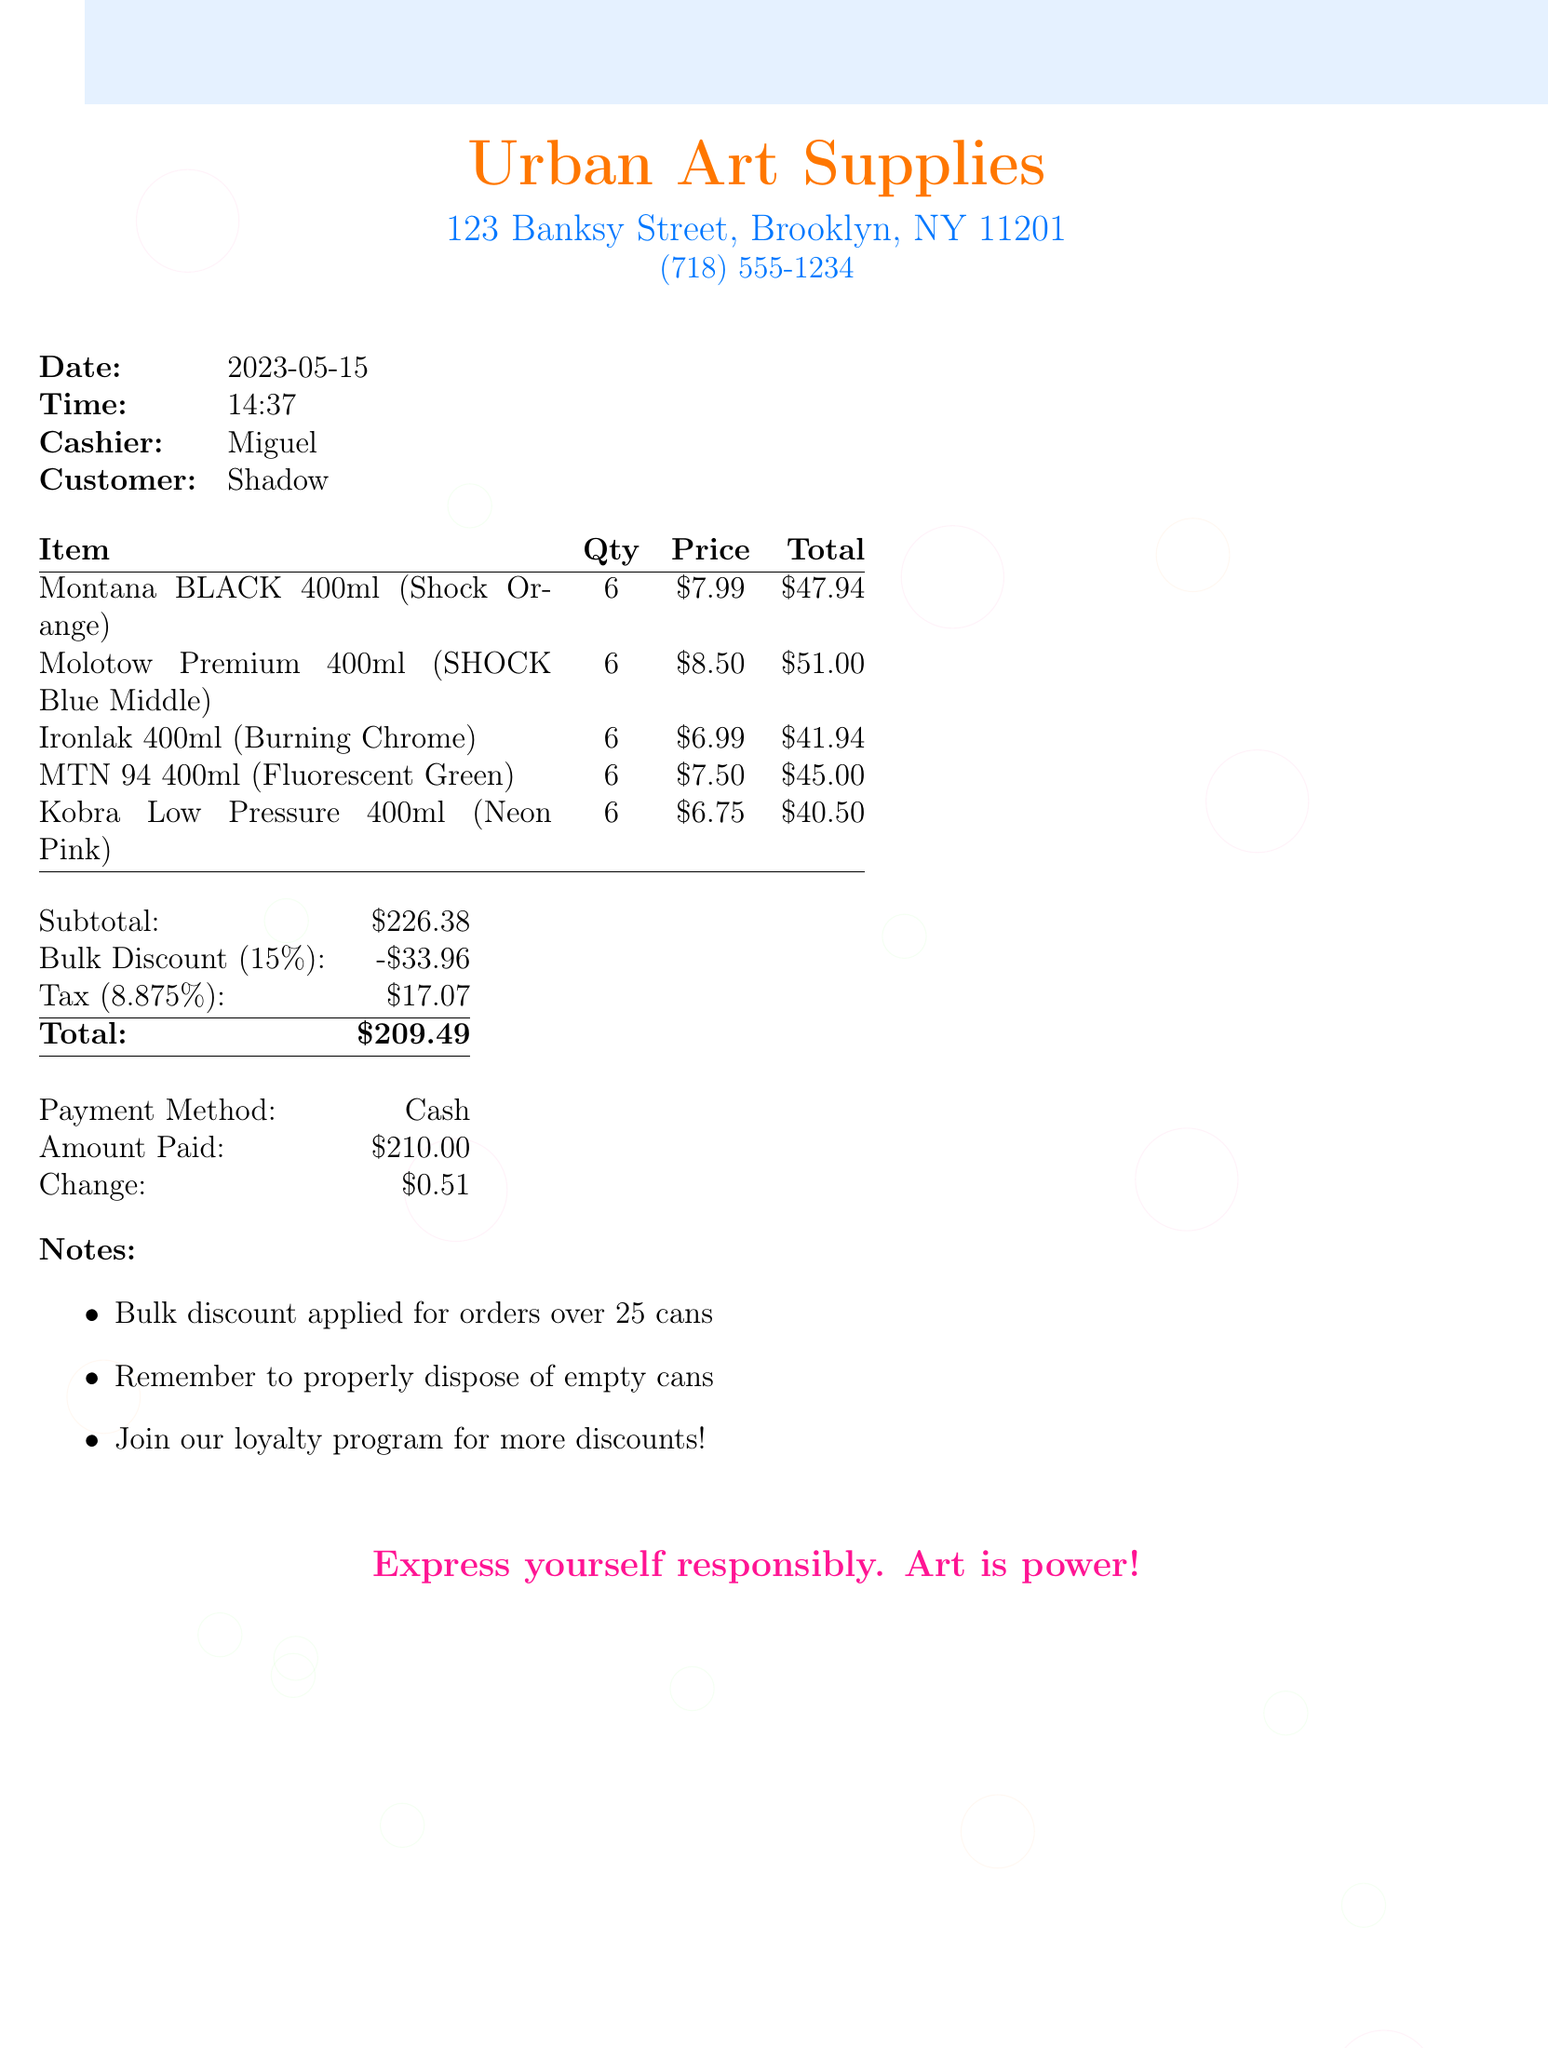What is the date of the receipt? The date of the receipt is stated directly in the document under the date section.
Answer: 2023-05-15 Who was the cashier? The name of the cashier is provided in the document under the cashier section.
Answer: Miguel How many spray paint cans were purchased in total? The total quantity of spray paint cans is found by adding the quantity from each item, and each item has a quantity of 6, totaling 30 cans.
Answer: 30 What was the subtotal amount? The subtotal reflects the sum of all items before discounts and taxes, as specified in the document.
Answer: $226.38 What percentage is the bulk discount? The bulk discount percentage is indicated clearly in the discount section of the receipt.
Answer: 15% What is the total amount after applying the discount and tax? The total amount is a calculation outlined in the receipt, showing what the customer paid after all adjustments.
Answer: $209.49 What color is the Montana BLACK spray paint? The color of the Montana BLACK spray paint is listed directly in the items table.
Answer: Shock Orange What is mentioned in the notes regarding empty cans? One of the notes includes information on proper disposal of materials after use, which is specifically detailed in the notes section.
Answer: Remember to properly dispose of empty cans What payment method was used? The payment method is explicitly mentioned in the payment information section of the receipt.
Answer: Cash 